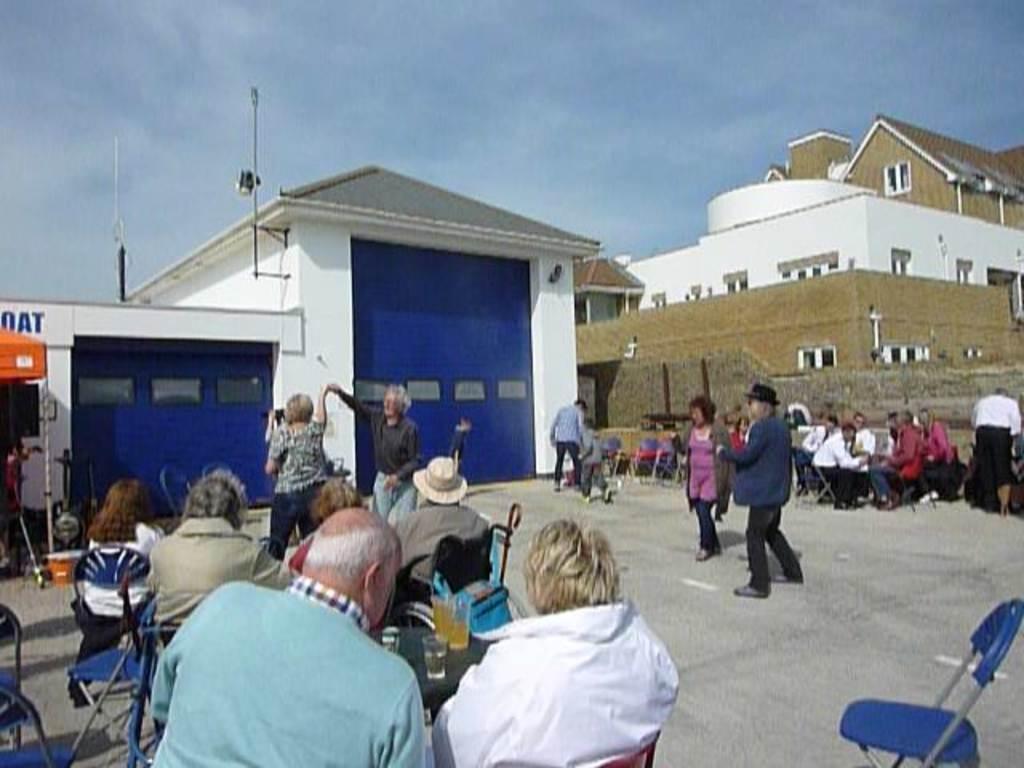Could you give a brief overview of what you see in this image? In the image in the center we can see few people were sitting and holding some objects. In the background we can see the sky,clouds,buildings,poles,tables,chairs,windows,few people were sitting and standing and few other objects. 